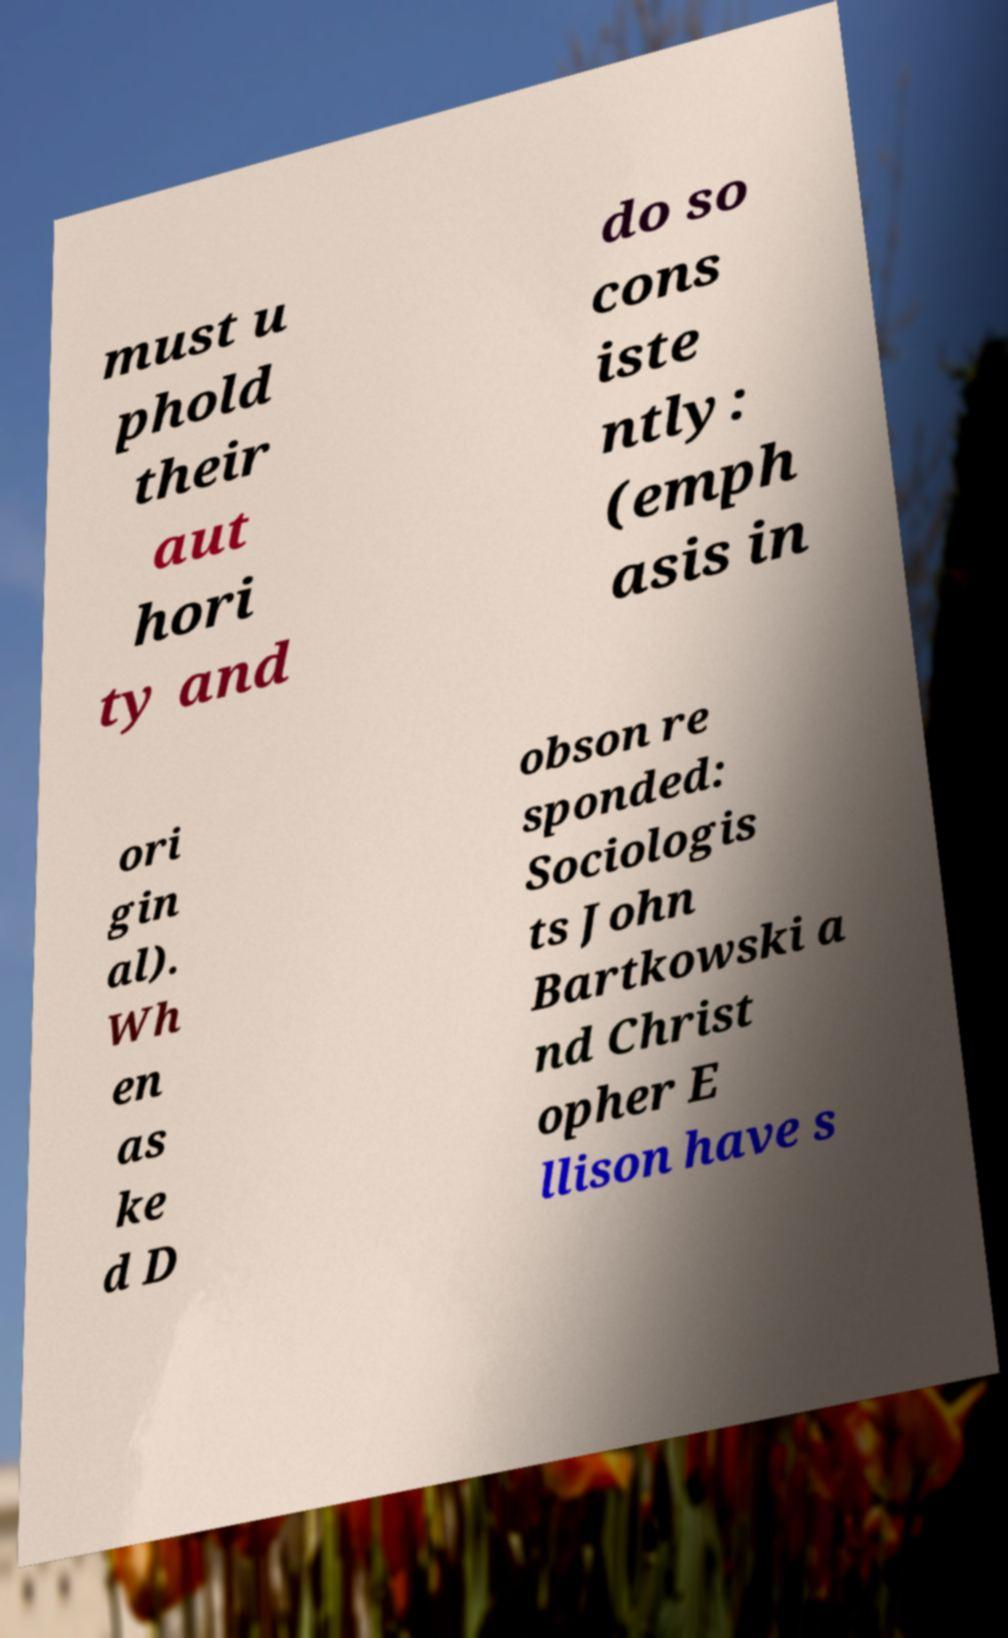Could you assist in decoding the text presented in this image and type it out clearly? must u phold their aut hori ty and do so cons iste ntly: (emph asis in ori gin al). Wh en as ke d D obson re sponded: Sociologis ts John Bartkowski a nd Christ opher E llison have s 